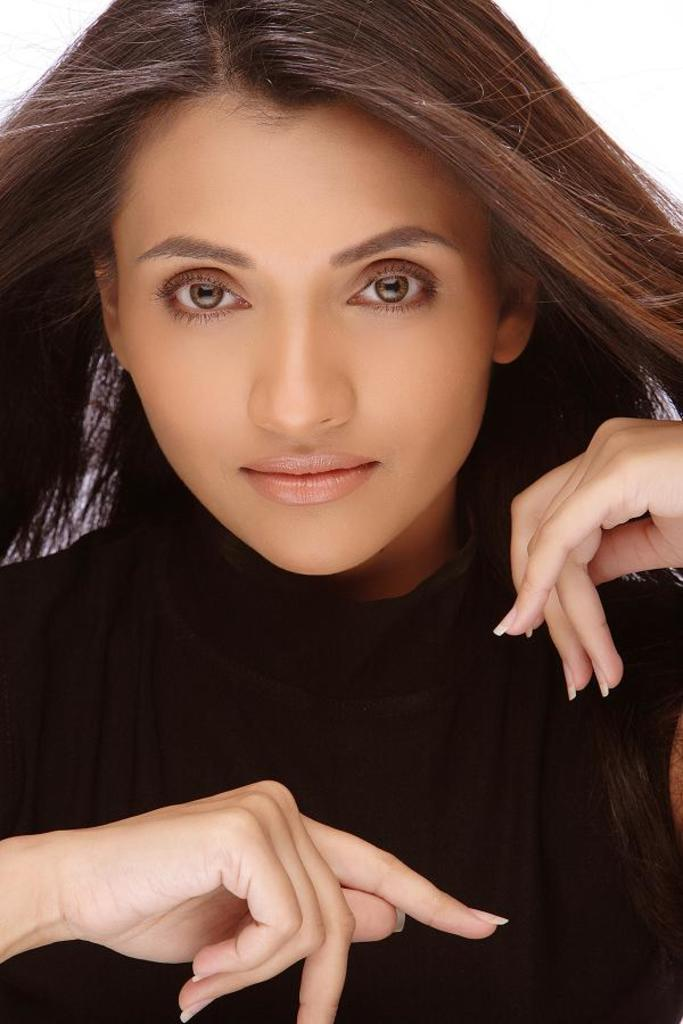What is the main subject of the image? The main subject of the image is a lady. What is the lady wearing in the image? The lady is wearing a black dress. Is the lady in the image engaged in a fight with a horse? There is no indication in the image that the lady is engaged in a fight with a horse, as no horse or fighting is depicted. 